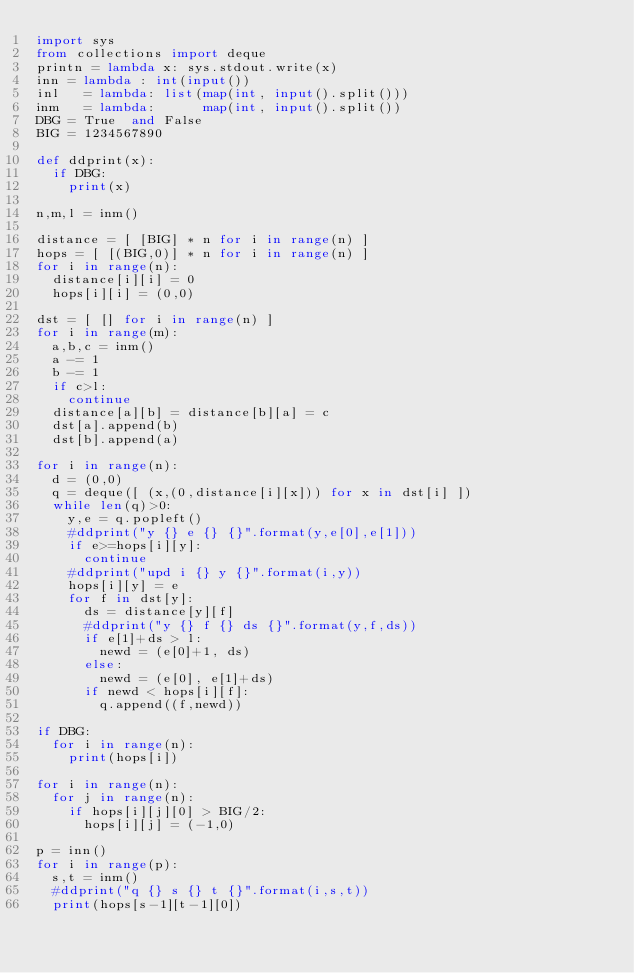Convert code to text. <code><loc_0><loc_0><loc_500><loc_500><_Python_>import sys
from collections import deque
printn = lambda x: sys.stdout.write(x)
inn = lambda : int(input())
inl   = lambda: list(map(int, input().split()))
inm   = lambda:      map(int, input().split()) 
DBG = True  and False
BIG = 1234567890

def ddprint(x):
  if DBG:
    print(x)

n,m,l = inm()

distance = [ [BIG] * n for i in range(n) ]
hops = [ [(BIG,0)] * n for i in range(n) ]
for i in range(n):
  distance[i][i] = 0
  hops[i][i] = (0,0)

dst = [ [] for i in range(n) ]
for i in range(m):
  a,b,c = inm()
  a -= 1
  b -= 1
  if c>l:
    continue
  distance[a][b] = distance[b][a] = c
  dst[a].append(b)
  dst[b].append(a)

for i in range(n):
  d = (0,0)
  q = deque([ (x,(0,distance[i][x])) for x in dst[i] ])
  while len(q)>0:
    y,e = q.popleft()
    #ddprint("y {} e {} {}".format(y,e[0],e[1]))
    if e>=hops[i][y]:
      continue
    #ddprint("upd i {} y {}".format(i,y))
    hops[i][y] = e
    for f in dst[y]:
      ds = distance[y][f]
      #ddprint("y {} f {} ds {}".format(y,f,ds))
      if e[1]+ds > l:
        newd = (e[0]+1, ds)
      else:
        newd = (e[0], e[1]+ds)
      if newd < hops[i][f]:
        q.append((f,newd))

if DBG:
  for i in range(n):
    print(hops[i])

for i in range(n):
  for j in range(n):
    if hops[i][j][0] > BIG/2:
      hops[i][j] = (-1,0)

p = inn()
for i in range(p):
  s,t = inm()
  #ddprint("q {} s {} t {}".format(i,s,t))
  print(hops[s-1][t-1][0])
</code> 